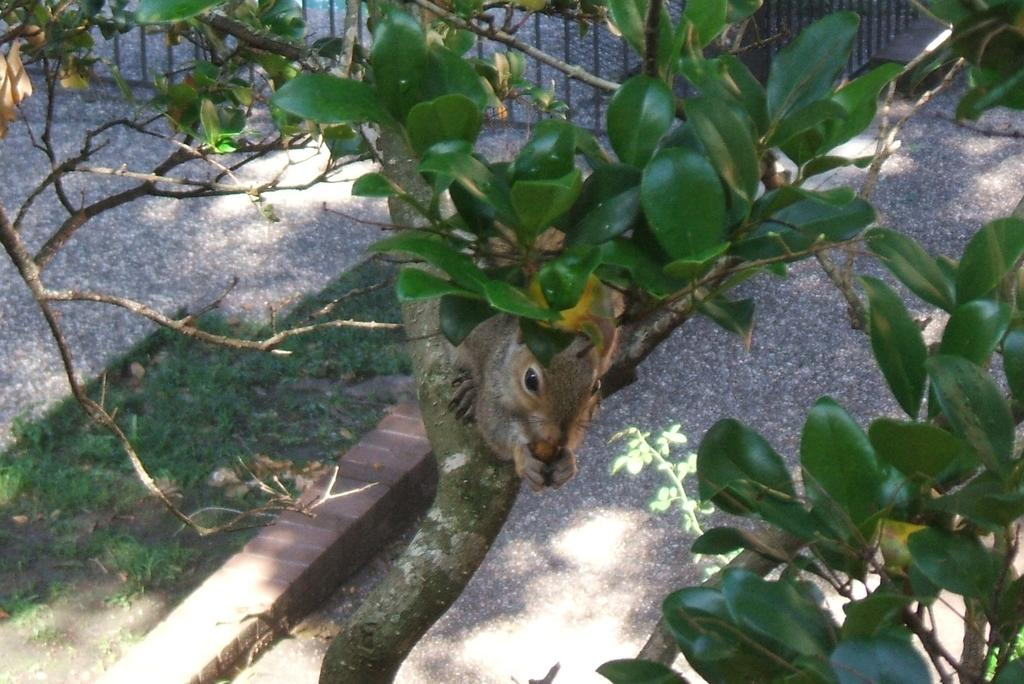What type of animal is in the image? There is an animal in the image, but the specific type cannot be determined from the provided facts. Where is the animal located in the image? The animal is on a tree in the image. What type of vegetation is visible in the image? There is grass in the image. What type of pig is saying good-bye to the idea in the image? There is no pig or idea present in the image, and therefore no such interaction can be observed. 